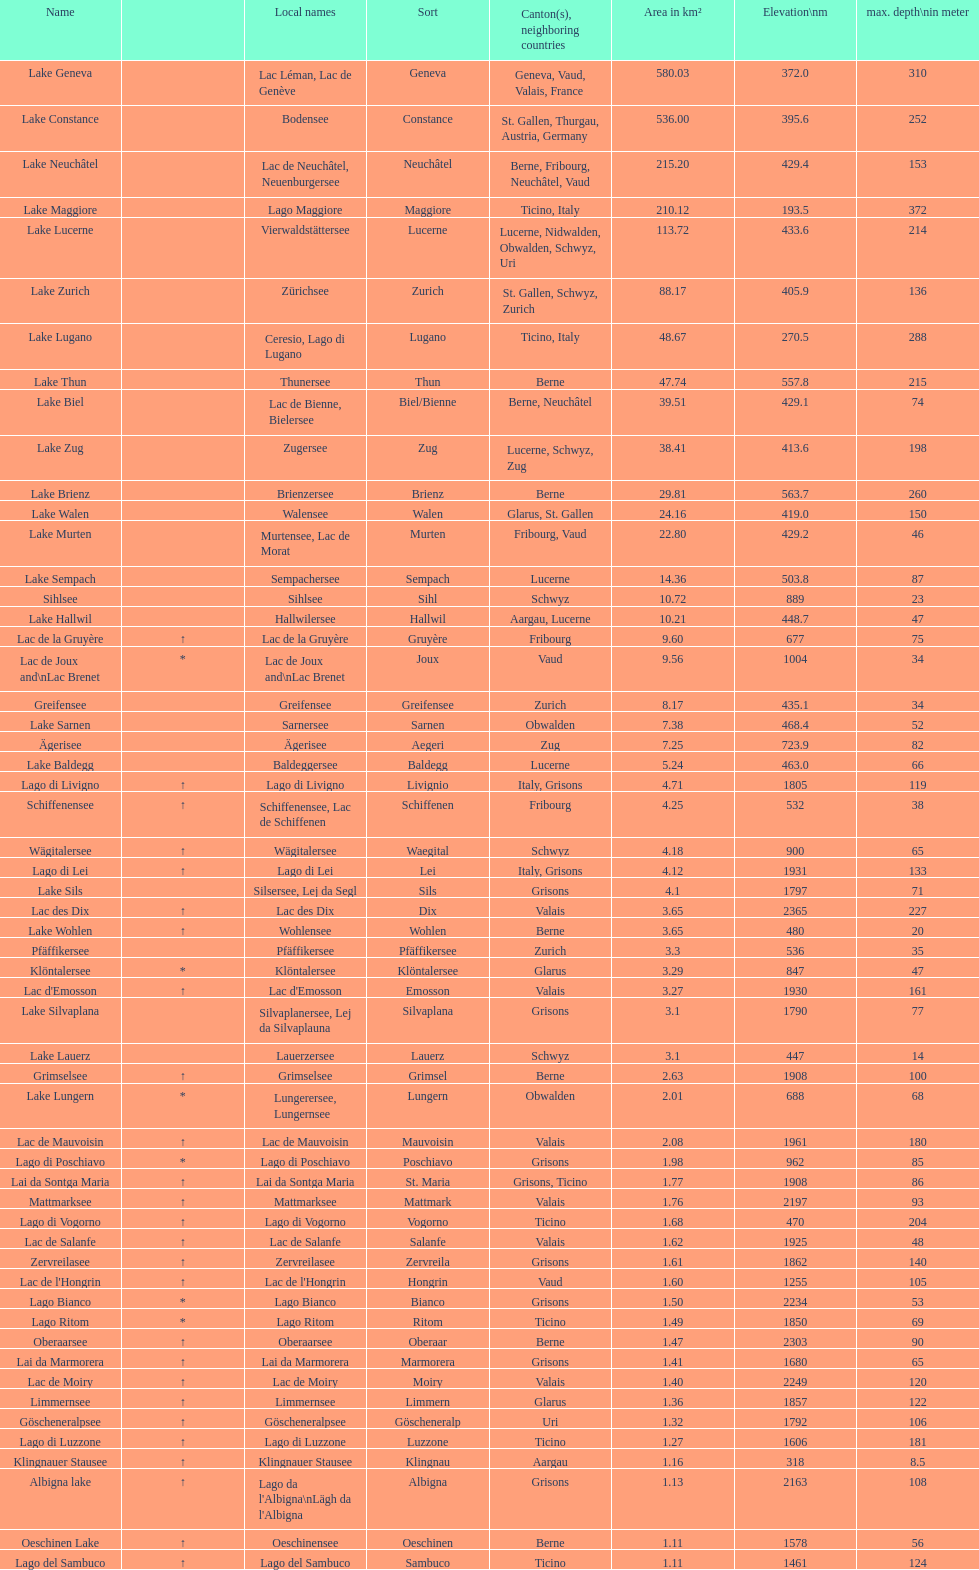What is the number of lakes that have an area less than 100 km squared? 51. 